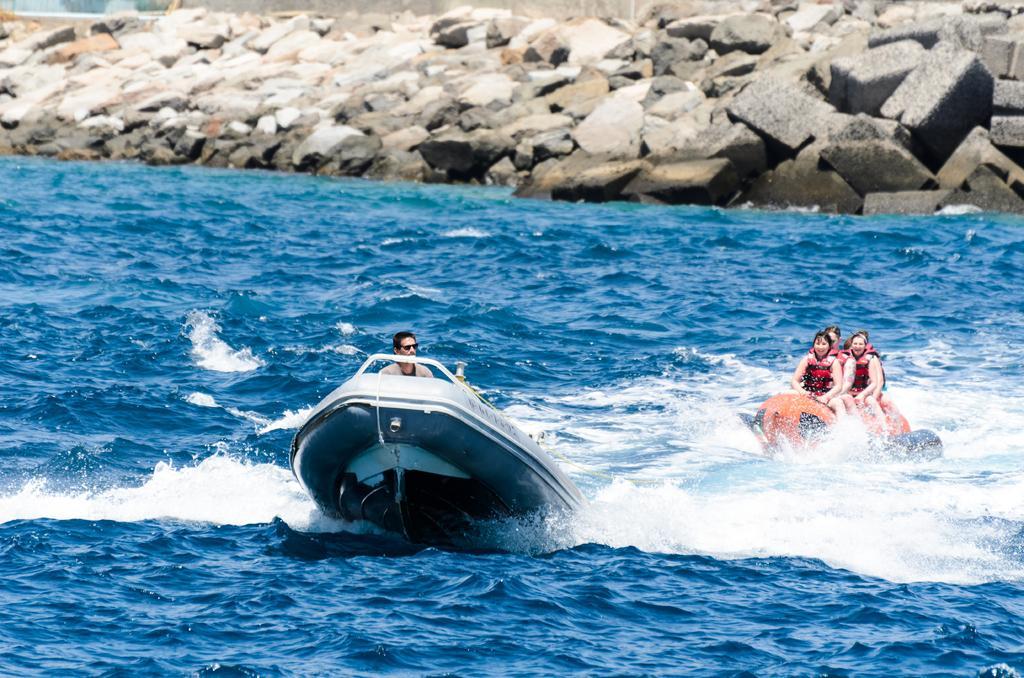Could you give a brief overview of what you see in this image? In this image, we can see a person and inflatable boat on the water. On the right side, we can see few people are wearing jackets. They are on the object. Top of the image, we can see rocks. 